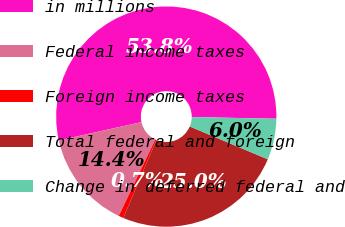<chart> <loc_0><loc_0><loc_500><loc_500><pie_chart><fcel>in millions<fcel>Federal income taxes<fcel>Foreign income taxes<fcel>Total federal and foreign<fcel>Change in deferred federal and<nl><fcel>53.78%<fcel>14.42%<fcel>0.72%<fcel>25.04%<fcel>6.03%<nl></chart> 